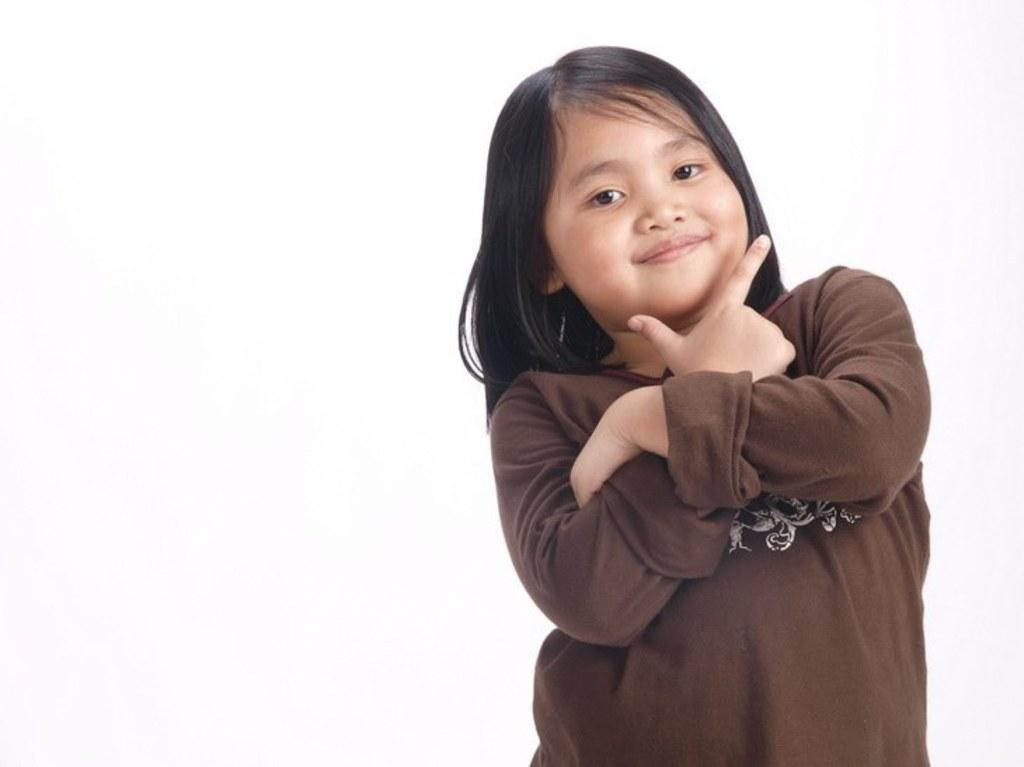What is the main subject of the image? There is a child in the image. What is the child wearing? The child is wearing a brown dress. What is the child doing in the image? The child is standing and smiling. What color is the background of the image? The background of the image is white. What type of soap is the child holding in the image? There is no soap present in the image; the child is not holding anything. 